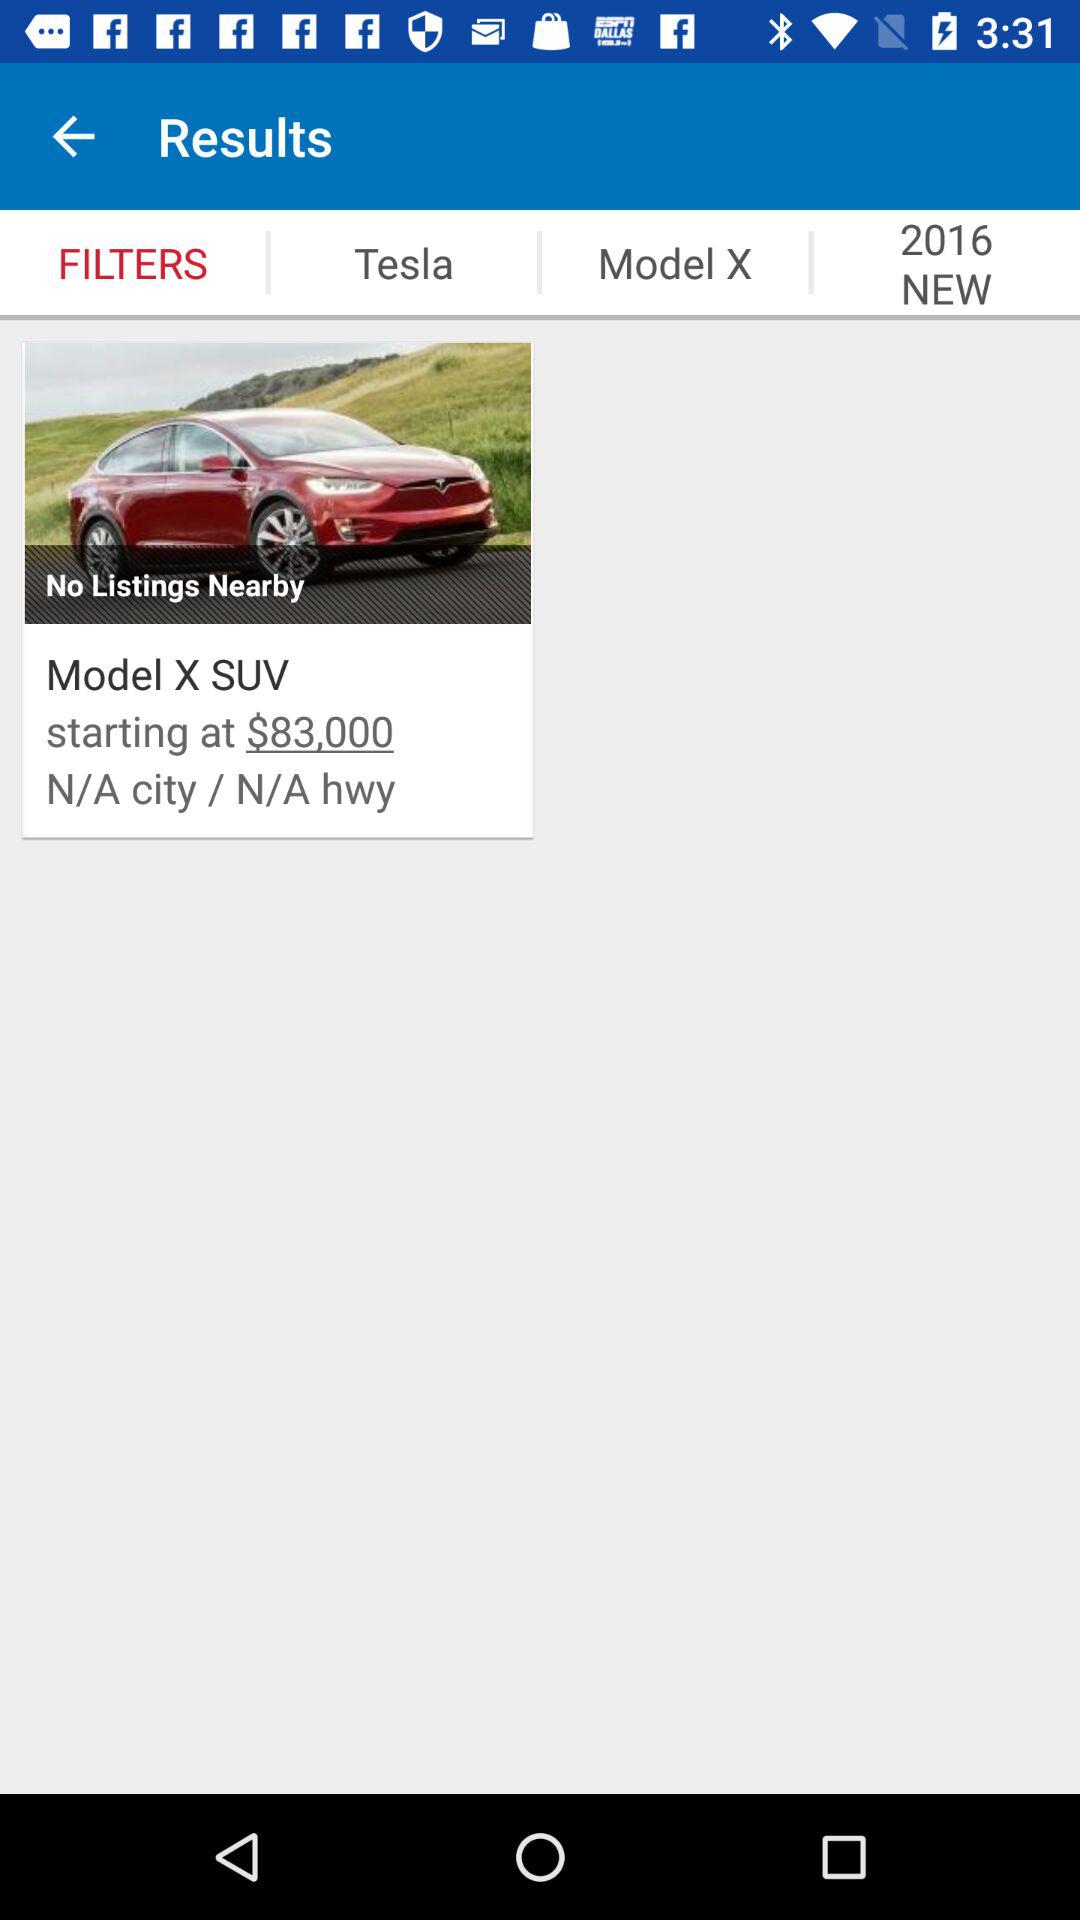Which option is selected? The selected option is "FILTERS". 